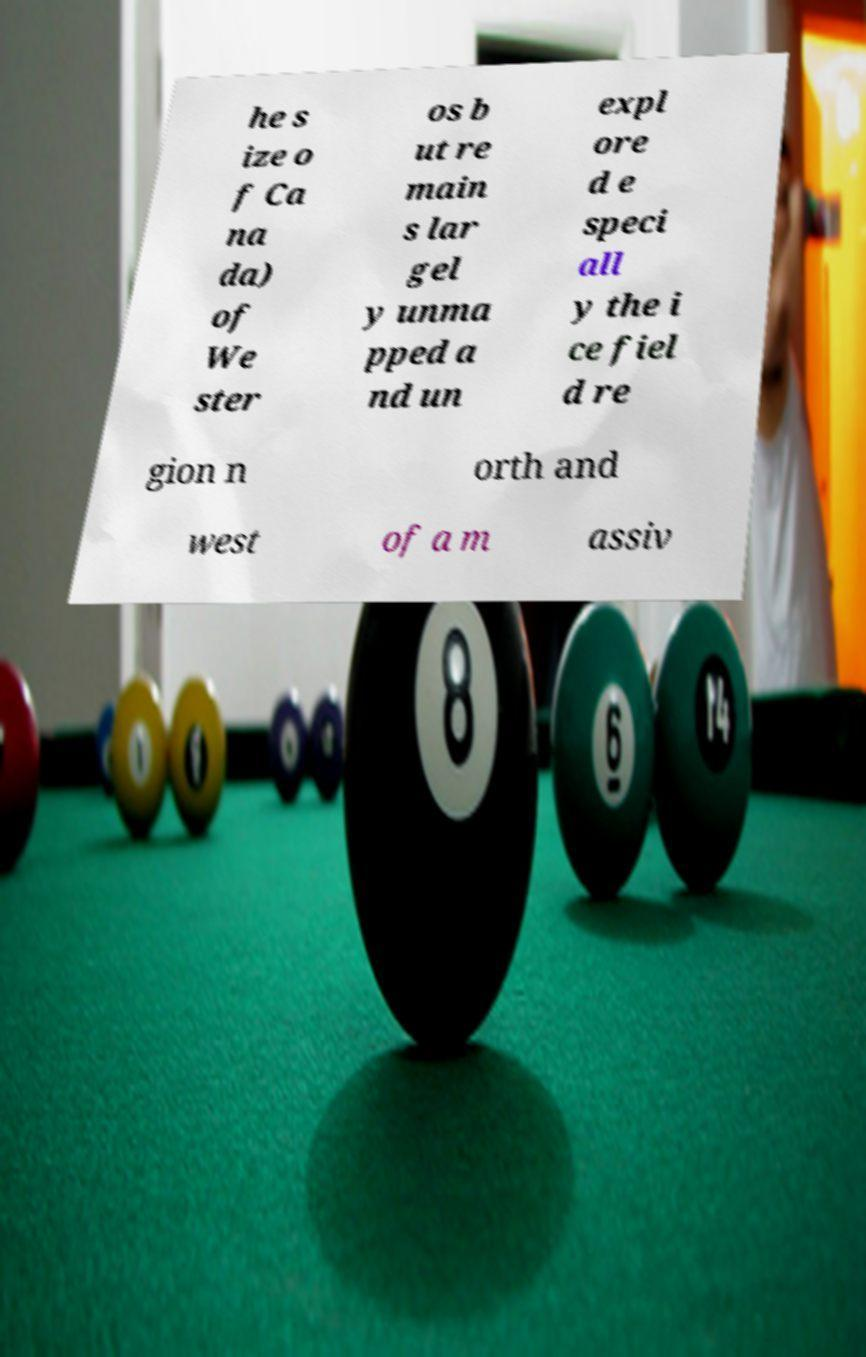Can you accurately transcribe the text from the provided image for me? he s ize o f Ca na da) of We ster os b ut re main s lar gel y unma pped a nd un expl ore d e speci all y the i ce fiel d re gion n orth and west of a m assiv 